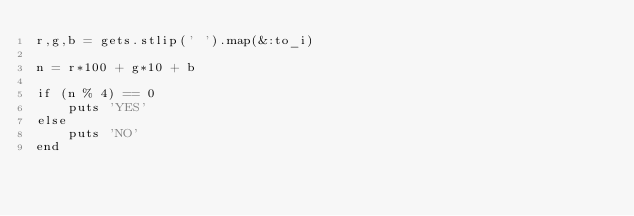Convert code to text. <code><loc_0><loc_0><loc_500><loc_500><_Ruby_>r,g,b = gets.stlip(' ').map(&:to_i)

n = r*100 + g*10 + b

if (n % 4) == 0
	puts 'YES'
else
	puts 'NO'
end
</code> 